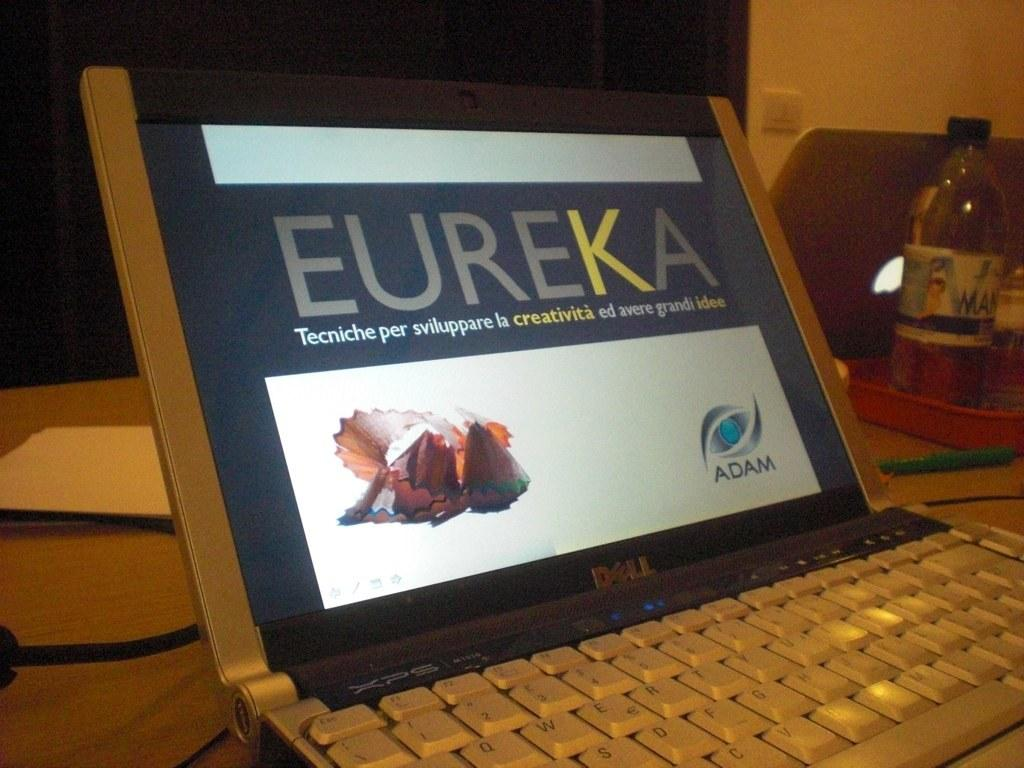<image>
Relay a brief, clear account of the picture shown. A small laptop with the words Eureka in bold on the screen. 